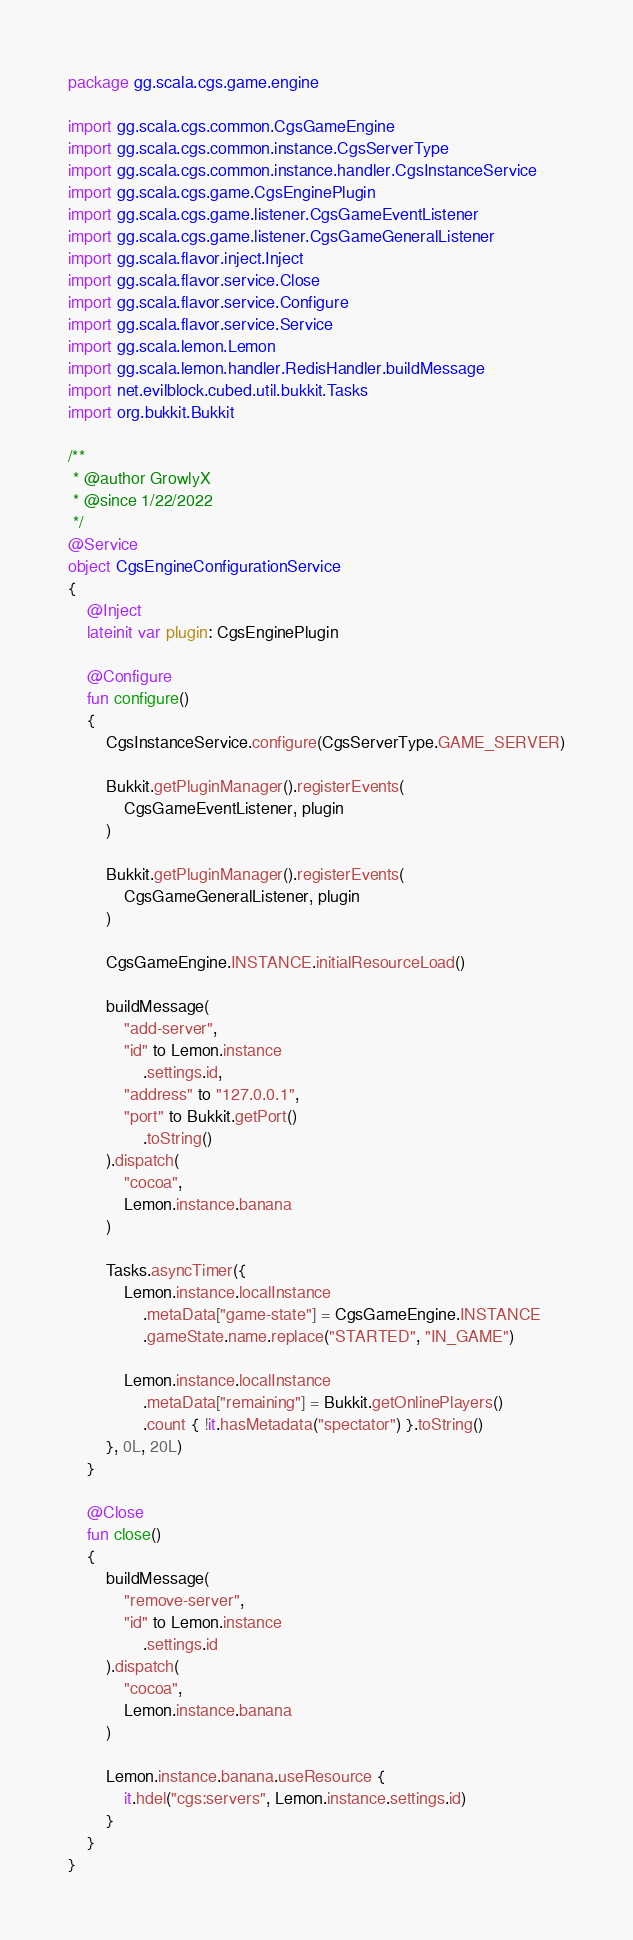<code> <loc_0><loc_0><loc_500><loc_500><_Kotlin_>package gg.scala.cgs.game.engine

import gg.scala.cgs.common.CgsGameEngine
import gg.scala.cgs.common.instance.CgsServerType
import gg.scala.cgs.common.instance.handler.CgsInstanceService
import gg.scala.cgs.game.CgsEnginePlugin
import gg.scala.cgs.game.listener.CgsGameEventListener
import gg.scala.cgs.game.listener.CgsGameGeneralListener
import gg.scala.flavor.inject.Inject
import gg.scala.flavor.service.Close
import gg.scala.flavor.service.Configure
import gg.scala.flavor.service.Service
import gg.scala.lemon.Lemon
import gg.scala.lemon.handler.RedisHandler.buildMessage
import net.evilblock.cubed.util.bukkit.Tasks
import org.bukkit.Bukkit

/**
 * @author GrowlyX
 * @since 1/22/2022
 */
@Service
object CgsEngineConfigurationService
{
    @Inject
    lateinit var plugin: CgsEnginePlugin

    @Configure
    fun configure()
    {
        CgsInstanceService.configure(CgsServerType.GAME_SERVER)

        Bukkit.getPluginManager().registerEvents(
            CgsGameEventListener, plugin
        )

        Bukkit.getPluginManager().registerEvents(
            CgsGameGeneralListener, plugin
        )

        CgsGameEngine.INSTANCE.initialResourceLoad()

        buildMessage(
            "add-server",
            "id" to Lemon.instance
                .settings.id,
            "address" to "127.0.0.1",
            "port" to Bukkit.getPort()
                .toString()
        ).dispatch(
            "cocoa",
            Lemon.instance.banana
        )

        Tasks.asyncTimer({
            Lemon.instance.localInstance
                .metaData["game-state"] = CgsGameEngine.INSTANCE
                .gameState.name.replace("STARTED", "IN_GAME")

            Lemon.instance.localInstance
                .metaData["remaining"] = Bukkit.getOnlinePlayers()
                .count { !it.hasMetadata("spectator") }.toString()
        }, 0L, 20L)
    }

    @Close
    fun close()
    {
        buildMessage(
            "remove-server",
            "id" to Lemon.instance
                .settings.id
        ).dispatch(
            "cocoa",
            Lemon.instance.banana
        )

        Lemon.instance.banana.useResource {
            it.hdel("cgs:servers", Lemon.instance.settings.id)
        }
    }
}
</code> 